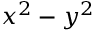<formula> <loc_0><loc_0><loc_500><loc_500>\ x ^ { 2 } - y ^ { 2 }</formula> 